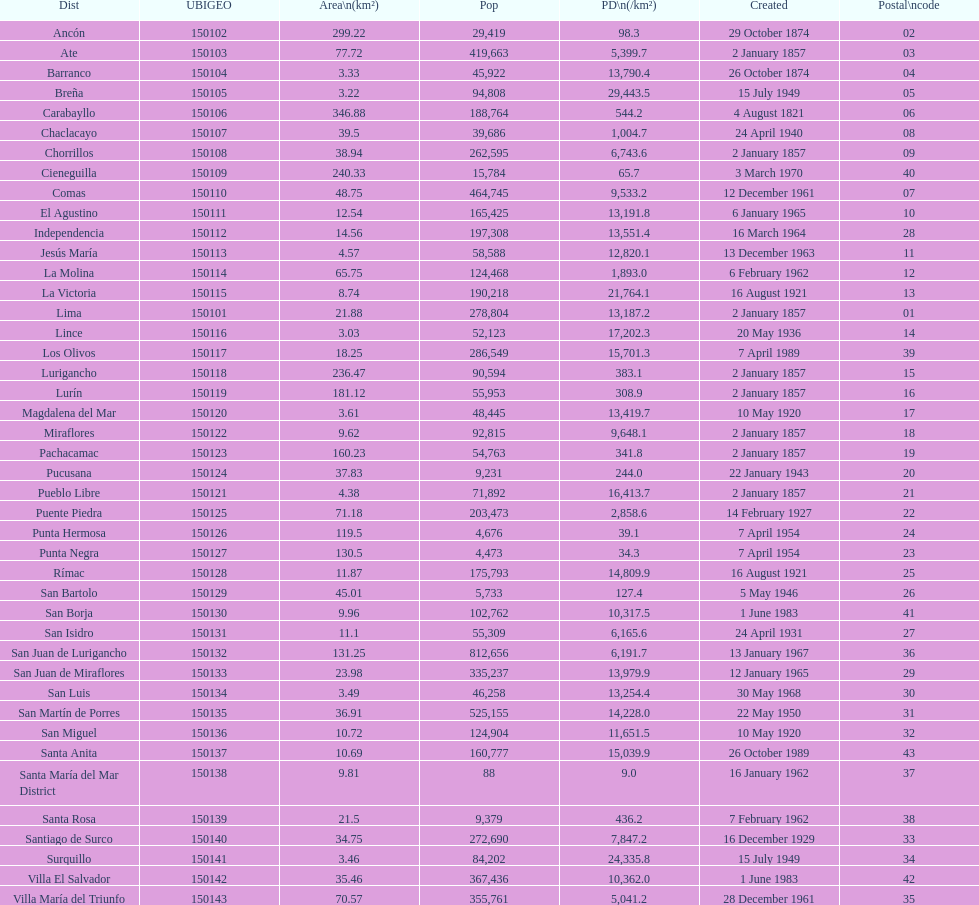What is the total number of districts of lima? 43. 